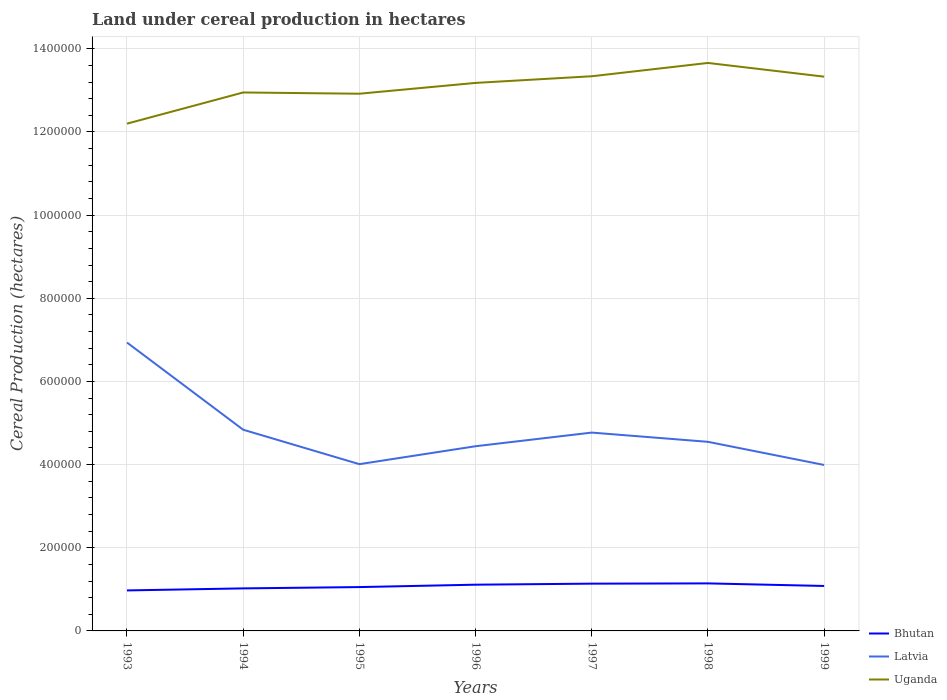How many different coloured lines are there?
Keep it short and to the point. 3. Does the line corresponding to Latvia intersect with the line corresponding to Bhutan?
Give a very brief answer. No. Is the number of lines equal to the number of legend labels?
Provide a succinct answer. Yes. Across all years, what is the maximum land under cereal production in Uganda?
Keep it short and to the point. 1.22e+06. In which year was the land under cereal production in Uganda maximum?
Ensure brevity in your answer.  1993. What is the total land under cereal production in Uganda in the graph?
Offer a terse response. -1.13e+05. What is the difference between the highest and the second highest land under cereal production in Latvia?
Keep it short and to the point. 2.94e+05. What is the difference between the highest and the lowest land under cereal production in Bhutan?
Ensure brevity in your answer.  4. Are the values on the major ticks of Y-axis written in scientific E-notation?
Your answer should be compact. No. Does the graph contain any zero values?
Make the answer very short. No. Does the graph contain grids?
Offer a very short reply. Yes. Where does the legend appear in the graph?
Make the answer very short. Bottom right. How many legend labels are there?
Ensure brevity in your answer.  3. What is the title of the graph?
Offer a terse response. Land under cereal production in hectares. What is the label or title of the X-axis?
Provide a short and direct response. Years. What is the label or title of the Y-axis?
Make the answer very short. Cereal Production (hectares). What is the Cereal Production (hectares) of Bhutan in 1993?
Keep it short and to the point. 9.74e+04. What is the Cereal Production (hectares) of Latvia in 1993?
Offer a terse response. 6.94e+05. What is the Cereal Production (hectares) of Uganda in 1993?
Offer a terse response. 1.22e+06. What is the Cereal Production (hectares) of Bhutan in 1994?
Your answer should be compact. 1.02e+05. What is the Cereal Production (hectares) in Latvia in 1994?
Provide a short and direct response. 4.84e+05. What is the Cereal Production (hectares) of Uganda in 1994?
Offer a terse response. 1.30e+06. What is the Cereal Production (hectares) of Bhutan in 1995?
Provide a short and direct response. 1.05e+05. What is the Cereal Production (hectares) of Latvia in 1995?
Make the answer very short. 4.01e+05. What is the Cereal Production (hectares) in Uganda in 1995?
Give a very brief answer. 1.29e+06. What is the Cereal Production (hectares) of Bhutan in 1996?
Provide a short and direct response. 1.11e+05. What is the Cereal Production (hectares) of Latvia in 1996?
Offer a terse response. 4.44e+05. What is the Cereal Production (hectares) in Uganda in 1996?
Your answer should be very brief. 1.32e+06. What is the Cereal Production (hectares) in Bhutan in 1997?
Make the answer very short. 1.14e+05. What is the Cereal Production (hectares) in Latvia in 1997?
Provide a short and direct response. 4.77e+05. What is the Cereal Production (hectares) of Uganda in 1997?
Offer a terse response. 1.33e+06. What is the Cereal Production (hectares) in Bhutan in 1998?
Provide a short and direct response. 1.14e+05. What is the Cereal Production (hectares) in Latvia in 1998?
Provide a short and direct response. 4.55e+05. What is the Cereal Production (hectares) in Uganda in 1998?
Provide a succinct answer. 1.37e+06. What is the Cereal Production (hectares) of Bhutan in 1999?
Ensure brevity in your answer.  1.08e+05. What is the Cereal Production (hectares) of Latvia in 1999?
Ensure brevity in your answer.  3.99e+05. What is the Cereal Production (hectares) of Uganda in 1999?
Your response must be concise. 1.33e+06. Across all years, what is the maximum Cereal Production (hectares) of Bhutan?
Offer a very short reply. 1.14e+05. Across all years, what is the maximum Cereal Production (hectares) in Latvia?
Make the answer very short. 6.94e+05. Across all years, what is the maximum Cereal Production (hectares) in Uganda?
Provide a succinct answer. 1.37e+06. Across all years, what is the minimum Cereal Production (hectares) in Bhutan?
Ensure brevity in your answer.  9.74e+04. Across all years, what is the minimum Cereal Production (hectares) in Latvia?
Ensure brevity in your answer.  3.99e+05. Across all years, what is the minimum Cereal Production (hectares) in Uganda?
Ensure brevity in your answer.  1.22e+06. What is the total Cereal Production (hectares) of Bhutan in the graph?
Your answer should be compact. 7.52e+05. What is the total Cereal Production (hectares) of Latvia in the graph?
Keep it short and to the point. 3.35e+06. What is the total Cereal Production (hectares) of Uganda in the graph?
Offer a terse response. 9.16e+06. What is the difference between the Cereal Production (hectares) of Bhutan in 1993 and that in 1994?
Ensure brevity in your answer.  -4869. What is the difference between the Cereal Production (hectares) in Latvia in 1993 and that in 1994?
Your response must be concise. 2.10e+05. What is the difference between the Cereal Production (hectares) of Uganda in 1993 and that in 1994?
Your answer should be compact. -7.50e+04. What is the difference between the Cereal Production (hectares) of Bhutan in 1993 and that in 1995?
Give a very brief answer. -8036. What is the difference between the Cereal Production (hectares) of Latvia in 1993 and that in 1995?
Offer a very short reply. 2.93e+05. What is the difference between the Cereal Production (hectares) in Uganda in 1993 and that in 1995?
Your response must be concise. -7.20e+04. What is the difference between the Cereal Production (hectares) in Bhutan in 1993 and that in 1996?
Offer a terse response. -1.38e+04. What is the difference between the Cereal Production (hectares) in Latvia in 1993 and that in 1996?
Make the answer very short. 2.49e+05. What is the difference between the Cereal Production (hectares) of Uganda in 1993 and that in 1996?
Ensure brevity in your answer.  -9.80e+04. What is the difference between the Cereal Production (hectares) of Bhutan in 1993 and that in 1997?
Keep it short and to the point. -1.63e+04. What is the difference between the Cereal Production (hectares) of Latvia in 1993 and that in 1997?
Offer a terse response. 2.17e+05. What is the difference between the Cereal Production (hectares) of Uganda in 1993 and that in 1997?
Ensure brevity in your answer.  -1.14e+05. What is the difference between the Cereal Production (hectares) in Bhutan in 1993 and that in 1998?
Your response must be concise. -1.69e+04. What is the difference between the Cereal Production (hectares) of Latvia in 1993 and that in 1998?
Offer a terse response. 2.39e+05. What is the difference between the Cereal Production (hectares) in Uganda in 1993 and that in 1998?
Your answer should be compact. -1.46e+05. What is the difference between the Cereal Production (hectares) of Bhutan in 1993 and that in 1999?
Your response must be concise. -1.07e+04. What is the difference between the Cereal Production (hectares) of Latvia in 1993 and that in 1999?
Your answer should be very brief. 2.94e+05. What is the difference between the Cereal Production (hectares) of Uganda in 1993 and that in 1999?
Keep it short and to the point. -1.13e+05. What is the difference between the Cereal Production (hectares) of Bhutan in 1994 and that in 1995?
Offer a very short reply. -3167. What is the difference between the Cereal Production (hectares) of Latvia in 1994 and that in 1995?
Offer a terse response. 8.28e+04. What is the difference between the Cereal Production (hectares) of Uganda in 1994 and that in 1995?
Keep it short and to the point. 3000. What is the difference between the Cereal Production (hectares) of Bhutan in 1994 and that in 1996?
Offer a terse response. -8895. What is the difference between the Cereal Production (hectares) in Latvia in 1994 and that in 1996?
Your answer should be compact. 3.97e+04. What is the difference between the Cereal Production (hectares) in Uganda in 1994 and that in 1996?
Keep it short and to the point. -2.30e+04. What is the difference between the Cereal Production (hectares) of Bhutan in 1994 and that in 1997?
Keep it short and to the point. -1.14e+04. What is the difference between the Cereal Production (hectares) in Latvia in 1994 and that in 1997?
Ensure brevity in your answer.  6900. What is the difference between the Cereal Production (hectares) of Uganda in 1994 and that in 1997?
Your answer should be compact. -3.90e+04. What is the difference between the Cereal Production (hectares) of Bhutan in 1994 and that in 1998?
Make the answer very short. -1.20e+04. What is the difference between the Cereal Production (hectares) in Latvia in 1994 and that in 1998?
Provide a succinct answer. 2.91e+04. What is the difference between the Cereal Production (hectares) of Uganda in 1994 and that in 1998?
Make the answer very short. -7.10e+04. What is the difference between the Cereal Production (hectares) of Bhutan in 1994 and that in 1999?
Make the answer very short. -5811. What is the difference between the Cereal Production (hectares) of Latvia in 1994 and that in 1999?
Provide a succinct answer. 8.48e+04. What is the difference between the Cereal Production (hectares) in Uganda in 1994 and that in 1999?
Your answer should be very brief. -3.80e+04. What is the difference between the Cereal Production (hectares) of Bhutan in 1995 and that in 1996?
Provide a short and direct response. -5728. What is the difference between the Cereal Production (hectares) in Latvia in 1995 and that in 1996?
Make the answer very short. -4.32e+04. What is the difference between the Cereal Production (hectares) of Uganda in 1995 and that in 1996?
Your answer should be very brief. -2.60e+04. What is the difference between the Cereal Production (hectares) in Bhutan in 1995 and that in 1997?
Ensure brevity in your answer.  -8221. What is the difference between the Cereal Production (hectares) of Latvia in 1995 and that in 1997?
Make the answer very short. -7.60e+04. What is the difference between the Cereal Production (hectares) in Uganda in 1995 and that in 1997?
Your response must be concise. -4.20e+04. What is the difference between the Cereal Production (hectares) in Bhutan in 1995 and that in 1998?
Give a very brief answer. -8857. What is the difference between the Cereal Production (hectares) in Latvia in 1995 and that in 1998?
Offer a very short reply. -5.38e+04. What is the difference between the Cereal Production (hectares) of Uganda in 1995 and that in 1998?
Ensure brevity in your answer.  -7.40e+04. What is the difference between the Cereal Production (hectares) in Bhutan in 1995 and that in 1999?
Your response must be concise. -2644. What is the difference between the Cereal Production (hectares) of Latvia in 1995 and that in 1999?
Your answer should be compact. 1950. What is the difference between the Cereal Production (hectares) in Uganda in 1995 and that in 1999?
Make the answer very short. -4.10e+04. What is the difference between the Cereal Production (hectares) of Bhutan in 1996 and that in 1997?
Ensure brevity in your answer.  -2493. What is the difference between the Cereal Production (hectares) in Latvia in 1996 and that in 1997?
Provide a short and direct response. -3.28e+04. What is the difference between the Cereal Production (hectares) in Uganda in 1996 and that in 1997?
Make the answer very short. -1.60e+04. What is the difference between the Cereal Production (hectares) of Bhutan in 1996 and that in 1998?
Provide a short and direct response. -3129. What is the difference between the Cereal Production (hectares) in Latvia in 1996 and that in 1998?
Provide a succinct answer. -1.06e+04. What is the difference between the Cereal Production (hectares) of Uganda in 1996 and that in 1998?
Keep it short and to the point. -4.80e+04. What is the difference between the Cereal Production (hectares) in Bhutan in 1996 and that in 1999?
Give a very brief answer. 3084. What is the difference between the Cereal Production (hectares) in Latvia in 1996 and that in 1999?
Your response must be concise. 4.51e+04. What is the difference between the Cereal Production (hectares) in Uganda in 1996 and that in 1999?
Your answer should be compact. -1.50e+04. What is the difference between the Cereal Production (hectares) of Bhutan in 1997 and that in 1998?
Make the answer very short. -636. What is the difference between the Cereal Production (hectares) of Latvia in 1997 and that in 1998?
Provide a succinct answer. 2.22e+04. What is the difference between the Cereal Production (hectares) in Uganda in 1997 and that in 1998?
Give a very brief answer. -3.20e+04. What is the difference between the Cereal Production (hectares) of Bhutan in 1997 and that in 1999?
Provide a short and direct response. 5577. What is the difference between the Cereal Production (hectares) in Latvia in 1997 and that in 1999?
Your answer should be very brief. 7.79e+04. What is the difference between the Cereal Production (hectares) in Bhutan in 1998 and that in 1999?
Your answer should be compact. 6213. What is the difference between the Cereal Production (hectares) of Latvia in 1998 and that in 1999?
Provide a short and direct response. 5.57e+04. What is the difference between the Cereal Production (hectares) of Uganda in 1998 and that in 1999?
Make the answer very short. 3.30e+04. What is the difference between the Cereal Production (hectares) of Bhutan in 1993 and the Cereal Production (hectares) of Latvia in 1994?
Offer a very short reply. -3.86e+05. What is the difference between the Cereal Production (hectares) of Bhutan in 1993 and the Cereal Production (hectares) of Uganda in 1994?
Your answer should be compact. -1.20e+06. What is the difference between the Cereal Production (hectares) in Latvia in 1993 and the Cereal Production (hectares) in Uganda in 1994?
Your response must be concise. -6.01e+05. What is the difference between the Cereal Production (hectares) of Bhutan in 1993 and the Cereal Production (hectares) of Latvia in 1995?
Give a very brief answer. -3.04e+05. What is the difference between the Cereal Production (hectares) in Bhutan in 1993 and the Cereal Production (hectares) in Uganda in 1995?
Keep it short and to the point. -1.19e+06. What is the difference between the Cereal Production (hectares) in Latvia in 1993 and the Cereal Production (hectares) in Uganda in 1995?
Ensure brevity in your answer.  -5.98e+05. What is the difference between the Cereal Production (hectares) in Bhutan in 1993 and the Cereal Production (hectares) in Latvia in 1996?
Keep it short and to the point. -3.47e+05. What is the difference between the Cereal Production (hectares) of Bhutan in 1993 and the Cereal Production (hectares) of Uganda in 1996?
Provide a succinct answer. -1.22e+06. What is the difference between the Cereal Production (hectares) of Latvia in 1993 and the Cereal Production (hectares) of Uganda in 1996?
Offer a very short reply. -6.24e+05. What is the difference between the Cereal Production (hectares) of Bhutan in 1993 and the Cereal Production (hectares) of Latvia in 1997?
Keep it short and to the point. -3.80e+05. What is the difference between the Cereal Production (hectares) of Bhutan in 1993 and the Cereal Production (hectares) of Uganda in 1997?
Your answer should be compact. -1.24e+06. What is the difference between the Cereal Production (hectares) of Latvia in 1993 and the Cereal Production (hectares) of Uganda in 1997?
Provide a short and direct response. -6.40e+05. What is the difference between the Cereal Production (hectares) of Bhutan in 1993 and the Cereal Production (hectares) of Latvia in 1998?
Your response must be concise. -3.57e+05. What is the difference between the Cereal Production (hectares) of Bhutan in 1993 and the Cereal Production (hectares) of Uganda in 1998?
Offer a very short reply. -1.27e+06. What is the difference between the Cereal Production (hectares) in Latvia in 1993 and the Cereal Production (hectares) in Uganda in 1998?
Provide a succinct answer. -6.72e+05. What is the difference between the Cereal Production (hectares) of Bhutan in 1993 and the Cereal Production (hectares) of Latvia in 1999?
Make the answer very short. -3.02e+05. What is the difference between the Cereal Production (hectares) of Bhutan in 1993 and the Cereal Production (hectares) of Uganda in 1999?
Your response must be concise. -1.24e+06. What is the difference between the Cereal Production (hectares) of Latvia in 1993 and the Cereal Production (hectares) of Uganda in 1999?
Keep it short and to the point. -6.39e+05. What is the difference between the Cereal Production (hectares) in Bhutan in 1994 and the Cereal Production (hectares) in Latvia in 1995?
Give a very brief answer. -2.99e+05. What is the difference between the Cereal Production (hectares) in Bhutan in 1994 and the Cereal Production (hectares) in Uganda in 1995?
Offer a very short reply. -1.19e+06. What is the difference between the Cereal Production (hectares) in Latvia in 1994 and the Cereal Production (hectares) in Uganda in 1995?
Offer a very short reply. -8.08e+05. What is the difference between the Cereal Production (hectares) of Bhutan in 1994 and the Cereal Production (hectares) of Latvia in 1996?
Keep it short and to the point. -3.42e+05. What is the difference between the Cereal Production (hectares) of Bhutan in 1994 and the Cereal Production (hectares) of Uganda in 1996?
Your answer should be very brief. -1.22e+06. What is the difference between the Cereal Production (hectares) of Latvia in 1994 and the Cereal Production (hectares) of Uganda in 1996?
Offer a terse response. -8.34e+05. What is the difference between the Cereal Production (hectares) in Bhutan in 1994 and the Cereal Production (hectares) in Latvia in 1997?
Your answer should be very brief. -3.75e+05. What is the difference between the Cereal Production (hectares) in Bhutan in 1994 and the Cereal Production (hectares) in Uganda in 1997?
Offer a very short reply. -1.23e+06. What is the difference between the Cereal Production (hectares) in Latvia in 1994 and the Cereal Production (hectares) in Uganda in 1997?
Give a very brief answer. -8.50e+05. What is the difference between the Cereal Production (hectares) in Bhutan in 1994 and the Cereal Production (hectares) in Latvia in 1998?
Ensure brevity in your answer.  -3.53e+05. What is the difference between the Cereal Production (hectares) in Bhutan in 1994 and the Cereal Production (hectares) in Uganda in 1998?
Offer a very short reply. -1.26e+06. What is the difference between the Cereal Production (hectares) of Latvia in 1994 and the Cereal Production (hectares) of Uganda in 1998?
Your answer should be compact. -8.82e+05. What is the difference between the Cereal Production (hectares) in Bhutan in 1994 and the Cereal Production (hectares) in Latvia in 1999?
Provide a succinct answer. -2.97e+05. What is the difference between the Cereal Production (hectares) in Bhutan in 1994 and the Cereal Production (hectares) in Uganda in 1999?
Make the answer very short. -1.23e+06. What is the difference between the Cereal Production (hectares) in Latvia in 1994 and the Cereal Production (hectares) in Uganda in 1999?
Make the answer very short. -8.49e+05. What is the difference between the Cereal Production (hectares) in Bhutan in 1995 and the Cereal Production (hectares) in Latvia in 1996?
Keep it short and to the point. -3.39e+05. What is the difference between the Cereal Production (hectares) of Bhutan in 1995 and the Cereal Production (hectares) of Uganda in 1996?
Your response must be concise. -1.21e+06. What is the difference between the Cereal Production (hectares) of Latvia in 1995 and the Cereal Production (hectares) of Uganda in 1996?
Offer a terse response. -9.17e+05. What is the difference between the Cereal Production (hectares) of Bhutan in 1995 and the Cereal Production (hectares) of Latvia in 1997?
Your answer should be compact. -3.72e+05. What is the difference between the Cereal Production (hectares) of Bhutan in 1995 and the Cereal Production (hectares) of Uganda in 1997?
Offer a very short reply. -1.23e+06. What is the difference between the Cereal Production (hectares) of Latvia in 1995 and the Cereal Production (hectares) of Uganda in 1997?
Provide a succinct answer. -9.33e+05. What is the difference between the Cereal Production (hectares) in Bhutan in 1995 and the Cereal Production (hectares) in Latvia in 1998?
Provide a short and direct response. -3.49e+05. What is the difference between the Cereal Production (hectares) of Bhutan in 1995 and the Cereal Production (hectares) of Uganda in 1998?
Make the answer very short. -1.26e+06. What is the difference between the Cereal Production (hectares) in Latvia in 1995 and the Cereal Production (hectares) in Uganda in 1998?
Ensure brevity in your answer.  -9.65e+05. What is the difference between the Cereal Production (hectares) in Bhutan in 1995 and the Cereal Production (hectares) in Latvia in 1999?
Your answer should be very brief. -2.94e+05. What is the difference between the Cereal Production (hectares) of Bhutan in 1995 and the Cereal Production (hectares) of Uganda in 1999?
Your answer should be compact. -1.23e+06. What is the difference between the Cereal Production (hectares) of Latvia in 1995 and the Cereal Production (hectares) of Uganda in 1999?
Offer a terse response. -9.32e+05. What is the difference between the Cereal Production (hectares) of Bhutan in 1996 and the Cereal Production (hectares) of Latvia in 1997?
Provide a short and direct response. -3.66e+05. What is the difference between the Cereal Production (hectares) in Bhutan in 1996 and the Cereal Production (hectares) in Uganda in 1997?
Keep it short and to the point. -1.22e+06. What is the difference between the Cereal Production (hectares) of Latvia in 1996 and the Cereal Production (hectares) of Uganda in 1997?
Make the answer very short. -8.90e+05. What is the difference between the Cereal Production (hectares) in Bhutan in 1996 and the Cereal Production (hectares) in Latvia in 1998?
Keep it short and to the point. -3.44e+05. What is the difference between the Cereal Production (hectares) in Bhutan in 1996 and the Cereal Production (hectares) in Uganda in 1998?
Your answer should be very brief. -1.25e+06. What is the difference between the Cereal Production (hectares) of Latvia in 1996 and the Cereal Production (hectares) of Uganda in 1998?
Ensure brevity in your answer.  -9.22e+05. What is the difference between the Cereal Production (hectares) of Bhutan in 1996 and the Cereal Production (hectares) of Latvia in 1999?
Give a very brief answer. -2.88e+05. What is the difference between the Cereal Production (hectares) of Bhutan in 1996 and the Cereal Production (hectares) of Uganda in 1999?
Provide a succinct answer. -1.22e+06. What is the difference between the Cereal Production (hectares) in Latvia in 1996 and the Cereal Production (hectares) in Uganda in 1999?
Your response must be concise. -8.89e+05. What is the difference between the Cereal Production (hectares) in Bhutan in 1997 and the Cereal Production (hectares) in Latvia in 1998?
Keep it short and to the point. -3.41e+05. What is the difference between the Cereal Production (hectares) in Bhutan in 1997 and the Cereal Production (hectares) in Uganda in 1998?
Keep it short and to the point. -1.25e+06. What is the difference between the Cereal Production (hectares) of Latvia in 1997 and the Cereal Production (hectares) of Uganda in 1998?
Keep it short and to the point. -8.89e+05. What is the difference between the Cereal Production (hectares) of Bhutan in 1997 and the Cereal Production (hectares) of Latvia in 1999?
Provide a succinct answer. -2.85e+05. What is the difference between the Cereal Production (hectares) of Bhutan in 1997 and the Cereal Production (hectares) of Uganda in 1999?
Keep it short and to the point. -1.22e+06. What is the difference between the Cereal Production (hectares) of Latvia in 1997 and the Cereal Production (hectares) of Uganda in 1999?
Offer a terse response. -8.56e+05. What is the difference between the Cereal Production (hectares) in Bhutan in 1998 and the Cereal Production (hectares) in Latvia in 1999?
Provide a short and direct response. -2.85e+05. What is the difference between the Cereal Production (hectares) in Bhutan in 1998 and the Cereal Production (hectares) in Uganda in 1999?
Keep it short and to the point. -1.22e+06. What is the difference between the Cereal Production (hectares) of Latvia in 1998 and the Cereal Production (hectares) of Uganda in 1999?
Your response must be concise. -8.78e+05. What is the average Cereal Production (hectares) in Bhutan per year?
Your answer should be compact. 1.07e+05. What is the average Cereal Production (hectares) in Latvia per year?
Your answer should be very brief. 4.79e+05. What is the average Cereal Production (hectares) of Uganda per year?
Your answer should be very brief. 1.31e+06. In the year 1993, what is the difference between the Cereal Production (hectares) in Bhutan and Cereal Production (hectares) in Latvia?
Your response must be concise. -5.96e+05. In the year 1993, what is the difference between the Cereal Production (hectares) in Bhutan and Cereal Production (hectares) in Uganda?
Your answer should be compact. -1.12e+06. In the year 1993, what is the difference between the Cereal Production (hectares) of Latvia and Cereal Production (hectares) of Uganda?
Your response must be concise. -5.26e+05. In the year 1994, what is the difference between the Cereal Production (hectares) of Bhutan and Cereal Production (hectares) of Latvia?
Your response must be concise. -3.82e+05. In the year 1994, what is the difference between the Cereal Production (hectares) of Bhutan and Cereal Production (hectares) of Uganda?
Ensure brevity in your answer.  -1.19e+06. In the year 1994, what is the difference between the Cereal Production (hectares) in Latvia and Cereal Production (hectares) in Uganda?
Offer a very short reply. -8.11e+05. In the year 1995, what is the difference between the Cereal Production (hectares) of Bhutan and Cereal Production (hectares) of Latvia?
Give a very brief answer. -2.96e+05. In the year 1995, what is the difference between the Cereal Production (hectares) in Bhutan and Cereal Production (hectares) in Uganda?
Keep it short and to the point. -1.19e+06. In the year 1995, what is the difference between the Cereal Production (hectares) of Latvia and Cereal Production (hectares) of Uganda?
Your answer should be compact. -8.91e+05. In the year 1996, what is the difference between the Cereal Production (hectares) of Bhutan and Cereal Production (hectares) of Latvia?
Give a very brief answer. -3.33e+05. In the year 1996, what is the difference between the Cereal Production (hectares) in Bhutan and Cereal Production (hectares) in Uganda?
Make the answer very short. -1.21e+06. In the year 1996, what is the difference between the Cereal Production (hectares) of Latvia and Cereal Production (hectares) of Uganda?
Keep it short and to the point. -8.74e+05. In the year 1997, what is the difference between the Cereal Production (hectares) of Bhutan and Cereal Production (hectares) of Latvia?
Your response must be concise. -3.63e+05. In the year 1997, what is the difference between the Cereal Production (hectares) in Bhutan and Cereal Production (hectares) in Uganda?
Make the answer very short. -1.22e+06. In the year 1997, what is the difference between the Cereal Production (hectares) of Latvia and Cereal Production (hectares) of Uganda?
Your answer should be very brief. -8.57e+05. In the year 1998, what is the difference between the Cereal Production (hectares) of Bhutan and Cereal Production (hectares) of Latvia?
Ensure brevity in your answer.  -3.40e+05. In the year 1998, what is the difference between the Cereal Production (hectares) in Bhutan and Cereal Production (hectares) in Uganda?
Offer a very short reply. -1.25e+06. In the year 1998, what is the difference between the Cereal Production (hectares) in Latvia and Cereal Production (hectares) in Uganda?
Offer a terse response. -9.11e+05. In the year 1999, what is the difference between the Cereal Production (hectares) of Bhutan and Cereal Production (hectares) of Latvia?
Provide a succinct answer. -2.91e+05. In the year 1999, what is the difference between the Cereal Production (hectares) in Bhutan and Cereal Production (hectares) in Uganda?
Offer a terse response. -1.22e+06. In the year 1999, what is the difference between the Cereal Production (hectares) of Latvia and Cereal Production (hectares) of Uganda?
Your answer should be very brief. -9.34e+05. What is the ratio of the Cereal Production (hectares) of Bhutan in 1993 to that in 1994?
Your answer should be very brief. 0.95. What is the ratio of the Cereal Production (hectares) in Latvia in 1993 to that in 1994?
Your response must be concise. 1.43. What is the ratio of the Cereal Production (hectares) in Uganda in 1993 to that in 1994?
Make the answer very short. 0.94. What is the ratio of the Cereal Production (hectares) of Bhutan in 1993 to that in 1995?
Provide a short and direct response. 0.92. What is the ratio of the Cereal Production (hectares) in Latvia in 1993 to that in 1995?
Your answer should be compact. 1.73. What is the ratio of the Cereal Production (hectares) of Uganda in 1993 to that in 1995?
Make the answer very short. 0.94. What is the ratio of the Cereal Production (hectares) in Bhutan in 1993 to that in 1996?
Offer a very short reply. 0.88. What is the ratio of the Cereal Production (hectares) of Latvia in 1993 to that in 1996?
Offer a very short reply. 1.56. What is the ratio of the Cereal Production (hectares) in Uganda in 1993 to that in 1996?
Offer a terse response. 0.93. What is the ratio of the Cereal Production (hectares) of Bhutan in 1993 to that in 1997?
Keep it short and to the point. 0.86. What is the ratio of the Cereal Production (hectares) of Latvia in 1993 to that in 1997?
Provide a succinct answer. 1.45. What is the ratio of the Cereal Production (hectares) of Uganda in 1993 to that in 1997?
Make the answer very short. 0.91. What is the ratio of the Cereal Production (hectares) of Bhutan in 1993 to that in 1998?
Your answer should be compact. 0.85. What is the ratio of the Cereal Production (hectares) in Latvia in 1993 to that in 1998?
Your answer should be very brief. 1.53. What is the ratio of the Cereal Production (hectares) of Uganda in 1993 to that in 1998?
Your response must be concise. 0.89. What is the ratio of the Cereal Production (hectares) in Bhutan in 1993 to that in 1999?
Provide a succinct answer. 0.9. What is the ratio of the Cereal Production (hectares) in Latvia in 1993 to that in 1999?
Your answer should be compact. 1.74. What is the ratio of the Cereal Production (hectares) in Uganda in 1993 to that in 1999?
Keep it short and to the point. 0.92. What is the ratio of the Cereal Production (hectares) of Bhutan in 1994 to that in 1995?
Your response must be concise. 0.97. What is the ratio of the Cereal Production (hectares) in Latvia in 1994 to that in 1995?
Your answer should be compact. 1.21. What is the ratio of the Cereal Production (hectares) in Bhutan in 1994 to that in 1996?
Give a very brief answer. 0.92. What is the ratio of the Cereal Production (hectares) in Latvia in 1994 to that in 1996?
Offer a very short reply. 1.09. What is the ratio of the Cereal Production (hectares) in Uganda in 1994 to that in 1996?
Make the answer very short. 0.98. What is the ratio of the Cereal Production (hectares) of Bhutan in 1994 to that in 1997?
Your answer should be compact. 0.9. What is the ratio of the Cereal Production (hectares) in Latvia in 1994 to that in 1997?
Give a very brief answer. 1.01. What is the ratio of the Cereal Production (hectares) in Uganda in 1994 to that in 1997?
Provide a succinct answer. 0.97. What is the ratio of the Cereal Production (hectares) in Bhutan in 1994 to that in 1998?
Keep it short and to the point. 0.89. What is the ratio of the Cereal Production (hectares) in Latvia in 1994 to that in 1998?
Offer a very short reply. 1.06. What is the ratio of the Cereal Production (hectares) in Uganda in 1994 to that in 1998?
Provide a short and direct response. 0.95. What is the ratio of the Cereal Production (hectares) in Bhutan in 1994 to that in 1999?
Your answer should be very brief. 0.95. What is the ratio of the Cereal Production (hectares) in Latvia in 1994 to that in 1999?
Ensure brevity in your answer.  1.21. What is the ratio of the Cereal Production (hectares) in Uganda in 1994 to that in 1999?
Your answer should be very brief. 0.97. What is the ratio of the Cereal Production (hectares) of Bhutan in 1995 to that in 1996?
Provide a short and direct response. 0.95. What is the ratio of the Cereal Production (hectares) of Latvia in 1995 to that in 1996?
Your answer should be very brief. 0.9. What is the ratio of the Cereal Production (hectares) of Uganda in 1995 to that in 1996?
Your response must be concise. 0.98. What is the ratio of the Cereal Production (hectares) in Bhutan in 1995 to that in 1997?
Provide a short and direct response. 0.93. What is the ratio of the Cereal Production (hectares) of Latvia in 1995 to that in 1997?
Provide a succinct answer. 0.84. What is the ratio of the Cereal Production (hectares) in Uganda in 1995 to that in 1997?
Offer a very short reply. 0.97. What is the ratio of the Cereal Production (hectares) of Bhutan in 1995 to that in 1998?
Offer a terse response. 0.92. What is the ratio of the Cereal Production (hectares) of Latvia in 1995 to that in 1998?
Offer a very short reply. 0.88. What is the ratio of the Cereal Production (hectares) in Uganda in 1995 to that in 1998?
Keep it short and to the point. 0.95. What is the ratio of the Cereal Production (hectares) of Bhutan in 1995 to that in 1999?
Give a very brief answer. 0.98. What is the ratio of the Cereal Production (hectares) of Uganda in 1995 to that in 1999?
Keep it short and to the point. 0.97. What is the ratio of the Cereal Production (hectares) of Bhutan in 1996 to that in 1997?
Your answer should be compact. 0.98. What is the ratio of the Cereal Production (hectares) of Latvia in 1996 to that in 1997?
Give a very brief answer. 0.93. What is the ratio of the Cereal Production (hectares) in Uganda in 1996 to that in 1997?
Offer a terse response. 0.99. What is the ratio of the Cereal Production (hectares) in Bhutan in 1996 to that in 1998?
Your response must be concise. 0.97. What is the ratio of the Cereal Production (hectares) of Latvia in 1996 to that in 1998?
Provide a succinct answer. 0.98. What is the ratio of the Cereal Production (hectares) of Uganda in 1996 to that in 1998?
Your answer should be very brief. 0.96. What is the ratio of the Cereal Production (hectares) of Bhutan in 1996 to that in 1999?
Provide a succinct answer. 1.03. What is the ratio of the Cereal Production (hectares) in Latvia in 1996 to that in 1999?
Your answer should be compact. 1.11. What is the ratio of the Cereal Production (hectares) in Uganda in 1996 to that in 1999?
Your response must be concise. 0.99. What is the ratio of the Cereal Production (hectares) of Latvia in 1997 to that in 1998?
Your answer should be very brief. 1.05. What is the ratio of the Cereal Production (hectares) in Uganda in 1997 to that in 1998?
Your answer should be compact. 0.98. What is the ratio of the Cereal Production (hectares) in Bhutan in 1997 to that in 1999?
Give a very brief answer. 1.05. What is the ratio of the Cereal Production (hectares) in Latvia in 1997 to that in 1999?
Ensure brevity in your answer.  1.2. What is the ratio of the Cereal Production (hectares) in Uganda in 1997 to that in 1999?
Offer a terse response. 1. What is the ratio of the Cereal Production (hectares) of Bhutan in 1998 to that in 1999?
Keep it short and to the point. 1.06. What is the ratio of the Cereal Production (hectares) in Latvia in 1998 to that in 1999?
Keep it short and to the point. 1.14. What is the ratio of the Cereal Production (hectares) in Uganda in 1998 to that in 1999?
Your answer should be very brief. 1.02. What is the difference between the highest and the second highest Cereal Production (hectares) in Bhutan?
Ensure brevity in your answer.  636. What is the difference between the highest and the second highest Cereal Production (hectares) of Latvia?
Your response must be concise. 2.10e+05. What is the difference between the highest and the second highest Cereal Production (hectares) in Uganda?
Offer a terse response. 3.20e+04. What is the difference between the highest and the lowest Cereal Production (hectares) in Bhutan?
Offer a very short reply. 1.69e+04. What is the difference between the highest and the lowest Cereal Production (hectares) in Latvia?
Give a very brief answer. 2.94e+05. What is the difference between the highest and the lowest Cereal Production (hectares) in Uganda?
Your answer should be very brief. 1.46e+05. 